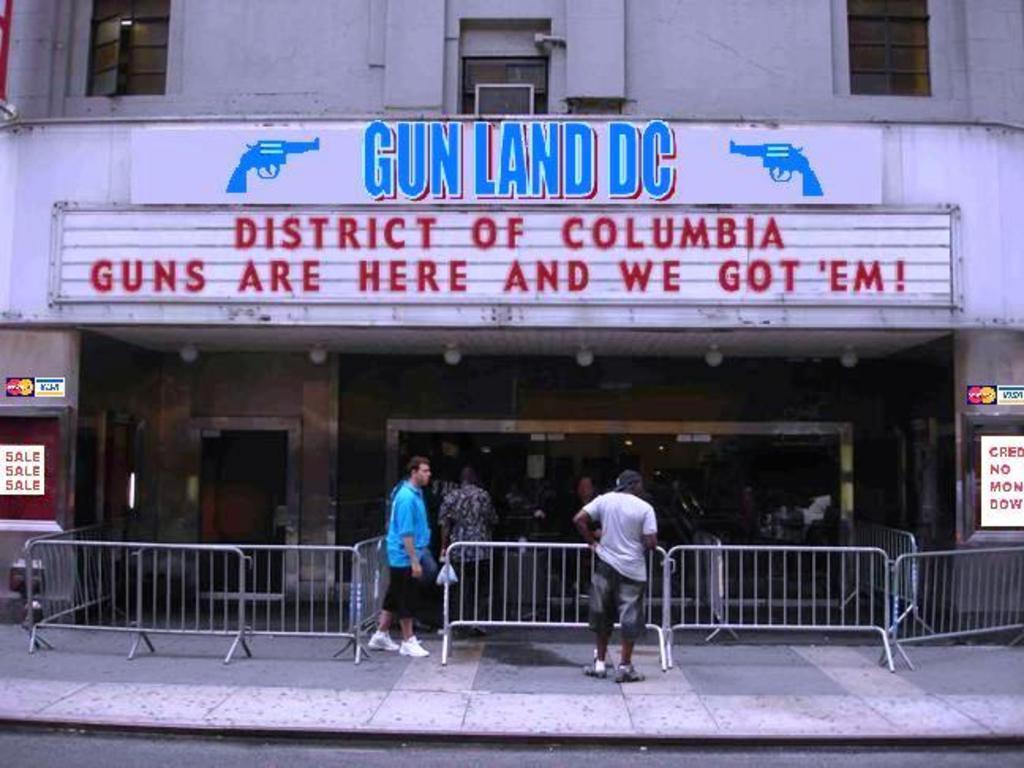Could you give a brief overview of what you see in this image? In this picture we can observe some people standing on the footpath. There is a railing. We can observe guns shop. There are blue and red color words on the wall of this building. 